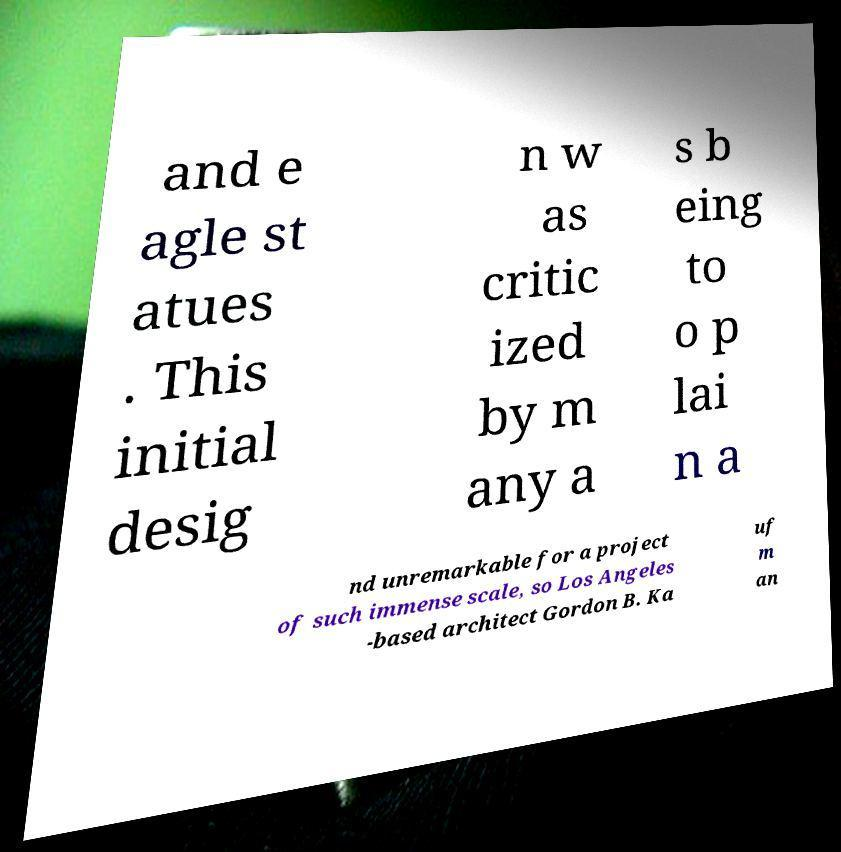There's text embedded in this image that I need extracted. Can you transcribe it verbatim? and e agle st atues . This initial desig n w as critic ized by m any a s b eing to o p lai n a nd unremarkable for a project of such immense scale, so Los Angeles -based architect Gordon B. Ka uf m an 